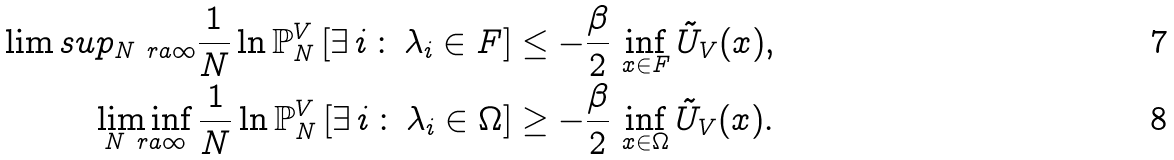<formula> <loc_0><loc_0><loc_500><loc_500>\lim s u p _ { N \ r a \infty } \frac { 1 } { N } \ln \mathbb { P } ^ { V } _ { N } \left [ \exists \, i \, \colon \, \lambda _ { i } \in F \right ] & \leq - \frac { \beta } { 2 } \, \inf _ { x \in F } \tilde { U } _ { V } ( x ) , \\ \liminf _ { N \ r a \infty } \frac { 1 } { N } \ln \mathbb { P } ^ { V } _ { N } \left [ \exists \, i \, \colon \, \lambda _ { i } \in \Omega \right ] & \geq - \frac { \beta } { 2 } \, \inf _ { x \in \Omega } \tilde { U } _ { V } ( x ) .</formula> 